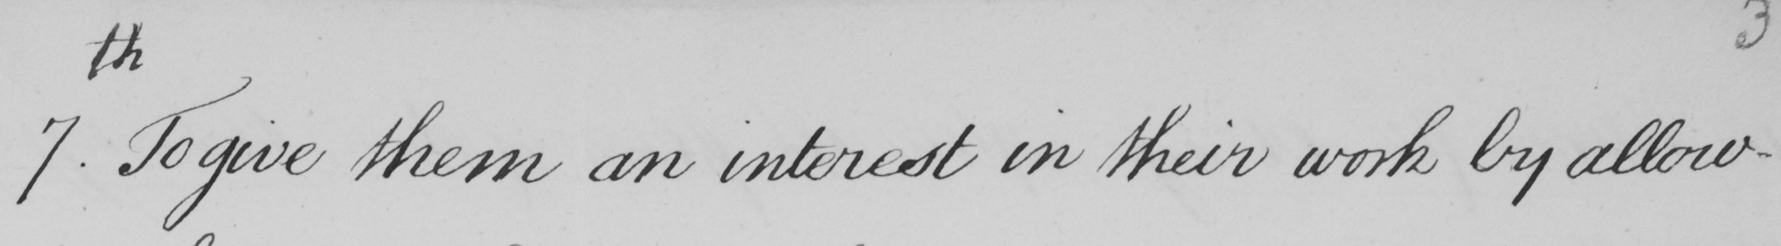Transcribe the text shown in this historical manuscript line. 7.th To give them an interest in their work by allow- 